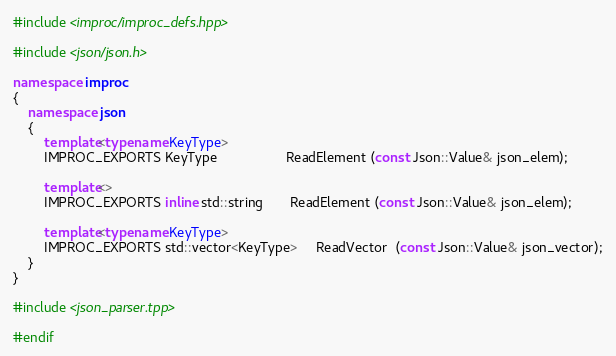Convert code to text. <code><loc_0><loc_0><loc_500><loc_500><_C++_>#include <improc/improc_defs.hpp>

#include <json/json.h>

namespace improc 
{
    namespace json
    {
        template<typename KeyType>
        IMPROC_EXPORTS KeyType                  ReadElement (const Json::Value& json_elem);

        template<>
        IMPROC_EXPORTS inline std::string       ReadElement (const Json::Value& json_elem);

        template<typename KeyType>
        IMPROC_EXPORTS std::vector<KeyType>     ReadVector  (const Json::Value& json_vector);
    }
}

#include <json_parser.tpp>

#endif
</code> 